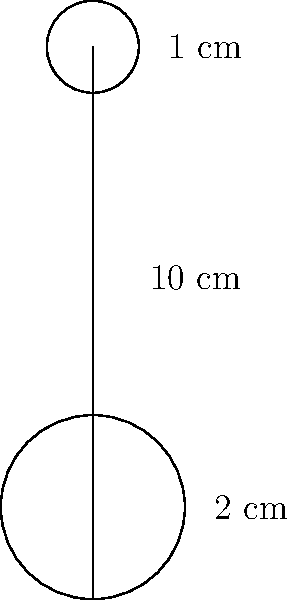As a comedian, you're always on the lookout for props. You've found a cylindrical microphone stand with a circular base of diameter 2 cm, a height of 10 cm, and a circular top of diameter 1 cm. Calculate the total surface area of this stand, assuming the base and top are solid. Round your answer to the nearest square centimeter. (Use $\pi = 3.14$) Let's break this down step-by-step:

1) We need to calculate the surface area of three parts:
   a) The circular base
   b) The cylindrical body
   c) The circular top

2) For the base:
   Area = $\pi r^2 = \pi (1 \text{ cm})^2 = 3.14 \text{ cm}^2$

3) For the cylindrical body:
   Area = $2\pi rh = 2\pi (1 \text{ cm})(10 \text{ cm}) = 62.8 \text{ cm}^2$

4) For the top:
   Area = $\pi r^2 = \pi (0.5 \text{ cm})^2 = 0.785 \text{ cm}^2$

5) Total surface area:
   $3.14 + 62.8 + 0.785 = 66.725 \text{ cm}^2$

6) Rounding to the nearest square centimeter:
   $66.725 \approx 67 \text{ cm}^2$
Answer: 67 cm² 